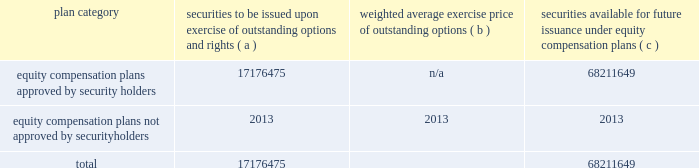The goldman sachs group , inc .
And subsidiaries item 9 .
Changes in and disagreements with accountants on accounting and financial disclosure there were no changes in or disagreements with accountants on accounting and financial disclosure during the last two years .
Item 9a .
Controls and procedures as of the end of the period covered by this report , an evaluation was carried out by goldman sachs 2019 management , with the participation of our chief executive officer and chief financial officer , of the effectiveness of our disclosure controls and procedures ( as defined in rule 13a-15 ( e ) under the exchange act ) .
Based upon that evaluation , our chief executive officer and chief financial officer concluded that these disclosure controls and procedures were effective as of the end of the period covered by this report .
In addition , no change in our internal control over financial reporting ( as defined in rule 13a-15 ( f ) under the exchange act ) occurred during the fourth quarter of our year ended december 31 , 2018 that has materially affected , or is reasonably likely to materially affect , our internal control over financial reporting .
Management 2019s report on internal control over financial reporting and the report of independent registered public accounting firm are set forth in part ii , item 8 of this form 10-k .
Item 9b .
Other information not applicable .
Part iii item 10 .
Directors , executive officers and corporate governance information relating to our executive officers is included on page 20 of this form 10-k .
Information relating to our directors , including our audit committee and audit committee financial experts and the procedures by which shareholders can recommend director nominees , and our executive officers will be in our definitive proxy statement for our 2019 annual meeting of shareholders , which will be filed within 120 days of the end of 2018 ( 2019 proxy statement ) and is incorporated in this form 10-k by reference .
Information relating to our code of business conduct and ethics , which applies to our senior financial officers , is included in 201cbusiness 2014 available information 201d in part i , item 1 of this form 10-k .
Item 11 .
Executive compensation information relating to our executive officer and director compensation and the compensation committee of the board will be in the 2019 proxy statement and is incorporated in this form 10-k by reference .
Item 12 .
Security ownership of certain beneficial owners and management and related stockholder matters information relating to security ownership of certain beneficial owners of our common stock and information relating to the security ownership of our management will be in the 2019 proxy statement and is incorporated in this form 10-k by reference .
The table below presents information as of december 31 , 2018 regarding securities to be issued pursuant to outstanding restricted stock units ( rsus ) and securities remaining available for issuance under our equity compensation plans that were in effect during 2018 .
Plan category securities to be issued exercise of outstanding options and rights ( a ) weighted average exercise price of outstanding options ( b ) securities available for future issuance under equity compensation plans ( c ) equity compensation plans approved by security holders 17176475 n/a 68211649 equity compensation plans not approved by security holders 2013 2013 2013 .
In the table above : 2030 securities to be issued upon exercise of outstanding options and rights includes 17176475 shares that may be issued pursuant to outstanding rsus .
These awards are subject to vesting and other conditions to the extent set forth in the respective award agreements , and the underlying shares will be delivered net of any required tax withholding .
As of december 31 , 2018 , there were no outstanding options .
2030 shares underlying rsus are deliverable without the payment of any consideration , and therefore these awards have not been taken into account in calculating the weighted average exercise price .
196 goldman sachs 2018 form 10-k .
What portion of the securities approved by security holders remains available for future issuance? 
Computations: (68211649 / (17176475 + 68211649))
Answer: 0.79884. 